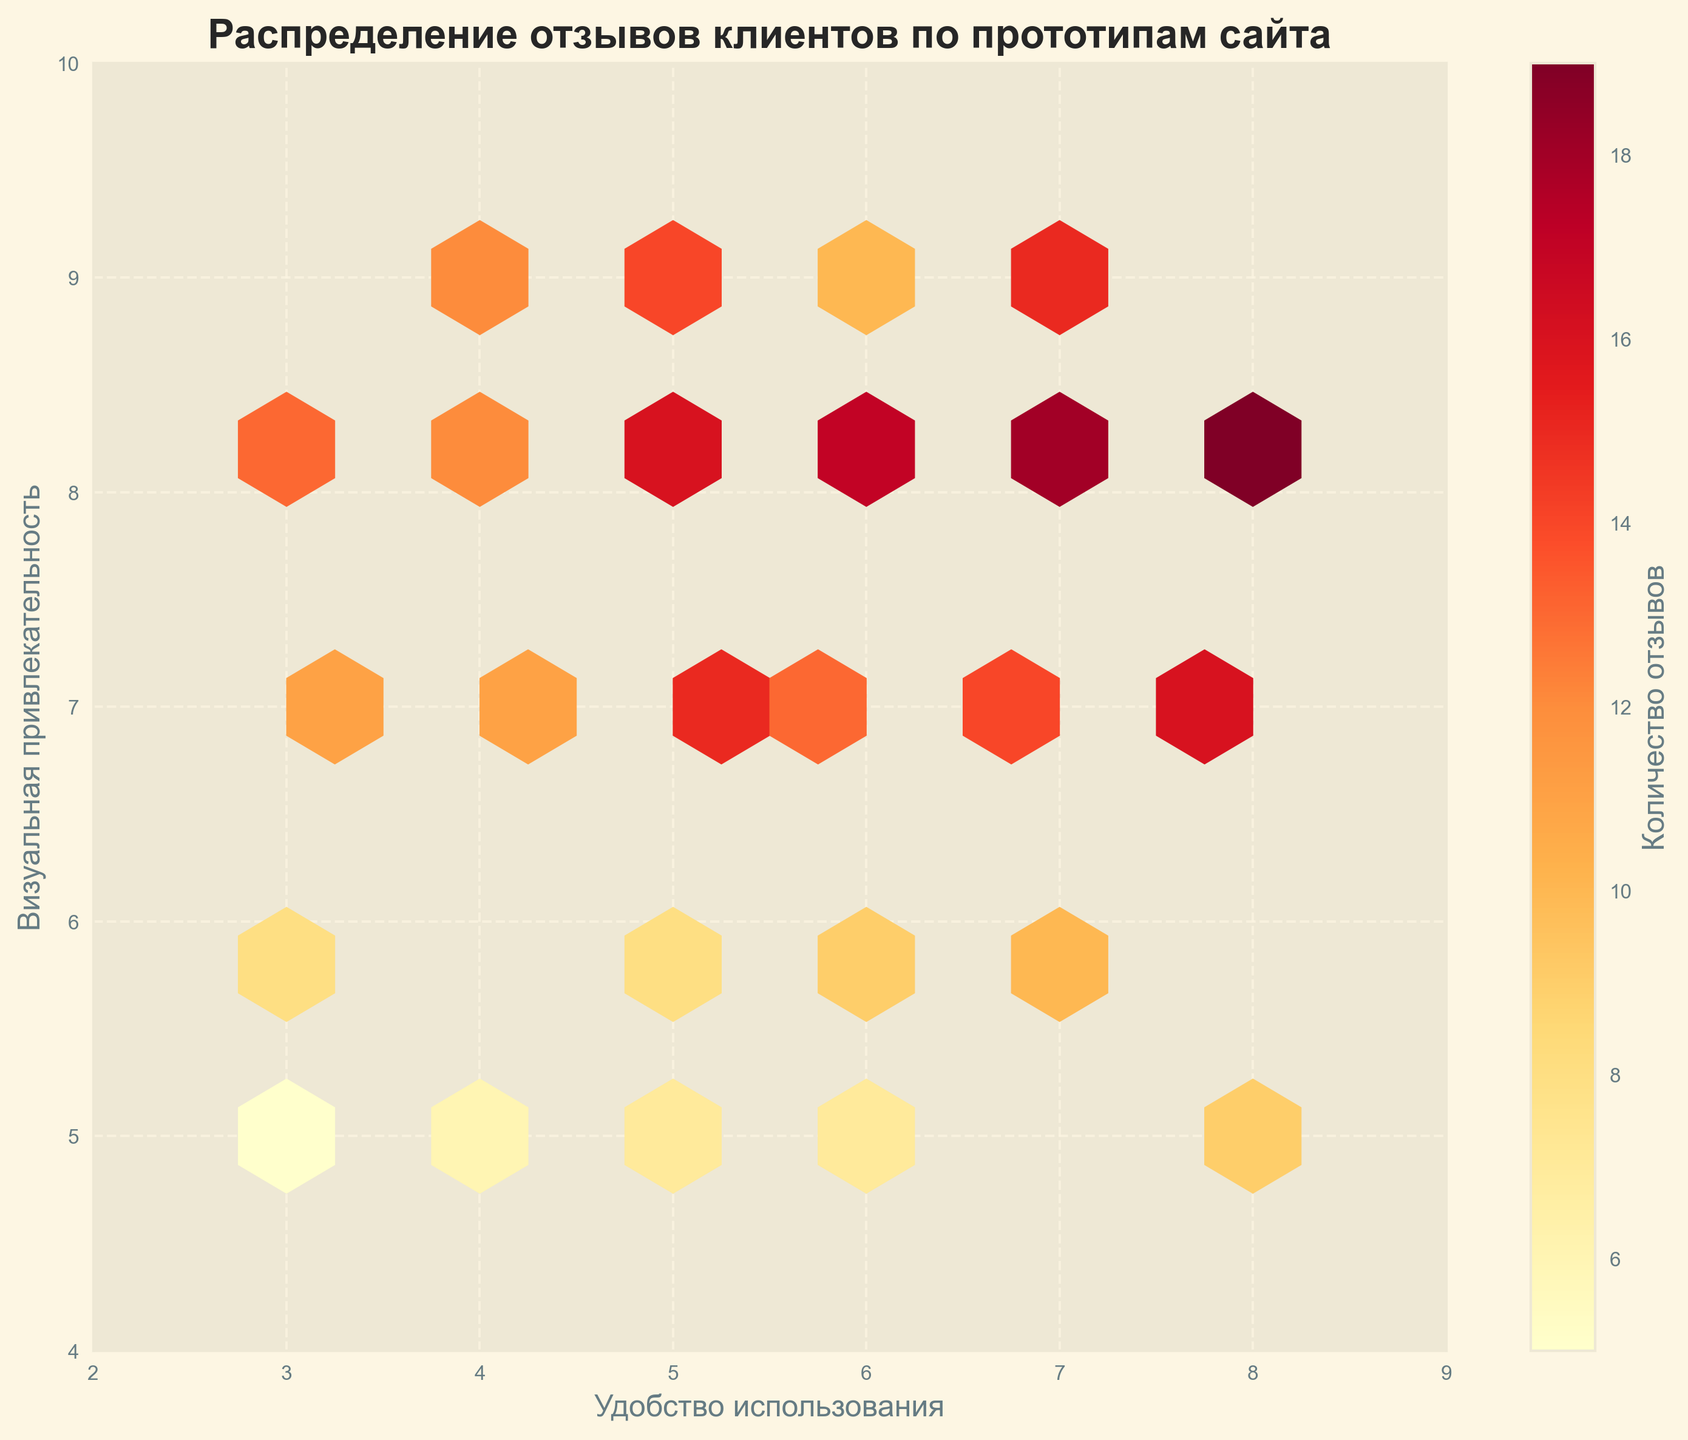What's the title of the figure? The title is written at the top of the figure and is the text that summarizes the main subject of the plot.
Answer: Распределение отзывов клиентов по прототипам сайта What are the labels of the x and y axes? The x-axis label is at the bottom of the x-axis and the y-axis label is at the left side of the y-axis.
Answer: Удобство использования, Визуальная привлекательность What's the color indicating the highest number of reviews? The color bar to the right of the plot shows a gradient from light to dark, with the darkest color representing the highest count.
Answer: Dark Red How many bins are there in the hexbin plot? By looking at the grid layout of the hexagons, count the total number of hex bins displayed in the plot.
Answer: 27 Is there a significant cluster of feedback in the plot? If yes, where is it located? Check for dense areas where hexagons are closely packed together and their colors indicate a higher count of reviews.
Answer: Yes, around (6, 8) What is the range of client feedback values indicated by the color bar? Look at the numerical values on both ends of the color bar to determine the range.
Answer: 5 to 19 Which area of the plot has the lowest feedback count? Identify the hexagons with the lightest color based on the color bar legend, indicating the lowest feedback count.
Answer: Around (3, 5) and (4, 5) What is the feedback count at the point (8, 8)? Find the hexagon located at (8, 8), check its color, and refer to the color bar to identify the corresponding value.
Answer: 19 How does the feedback on "Удобство использования" correlate with "Визуальная привлекательность"? Determine if there's a visible trend in how the density of hexagons changes along the axes, hinting at a correlation.
Answer: Positive correlation Where is the feedback count of 16 located on the plot? Identify the hexagons that match the color associated with the feedback count of 16 and note their corresponding coordinates.
Answer: (5, 8) and (8, 7) 